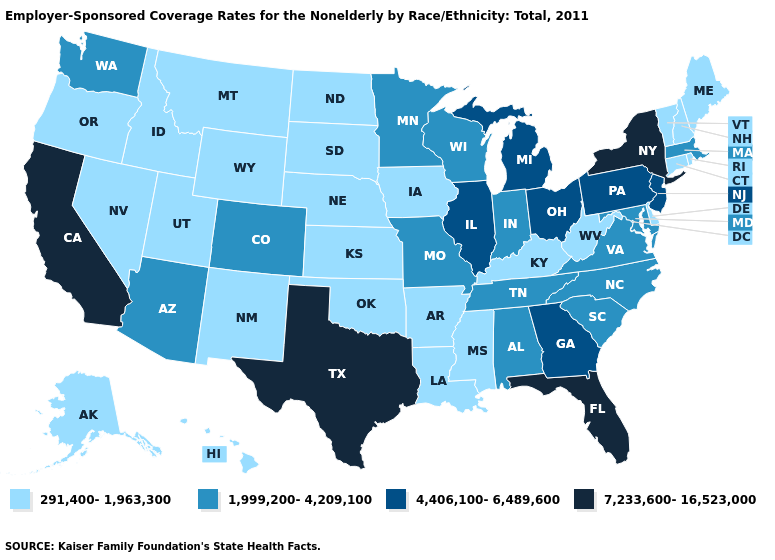How many symbols are there in the legend?
Be succinct. 4. Does Utah have the lowest value in the USA?
Be succinct. Yes. What is the value of Minnesota?
Give a very brief answer. 1,999,200-4,209,100. Does the first symbol in the legend represent the smallest category?
Be succinct. Yes. Is the legend a continuous bar?
Be succinct. No. Does North Dakota have a lower value than West Virginia?
Concise answer only. No. What is the value of Mississippi?
Concise answer only. 291,400-1,963,300. Which states have the lowest value in the MidWest?
Answer briefly. Iowa, Kansas, Nebraska, North Dakota, South Dakota. Among the states that border New York , does Vermont have the lowest value?
Keep it brief. Yes. Name the states that have a value in the range 7,233,600-16,523,000?
Be succinct. California, Florida, New York, Texas. Does the first symbol in the legend represent the smallest category?
Be succinct. Yes. Name the states that have a value in the range 291,400-1,963,300?
Short answer required. Alaska, Arkansas, Connecticut, Delaware, Hawaii, Idaho, Iowa, Kansas, Kentucky, Louisiana, Maine, Mississippi, Montana, Nebraska, Nevada, New Hampshire, New Mexico, North Dakota, Oklahoma, Oregon, Rhode Island, South Dakota, Utah, Vermont, West Virginia, Wyoming. What is the value of Ohio?
Write a very short answer. 4,406,100-6,489,600. What is the value of Texas?
Give a very brief answer. 7,233,600-16,523,000. Does Pennsylvania have the highest value in the USA?
Concise answer only. No. 